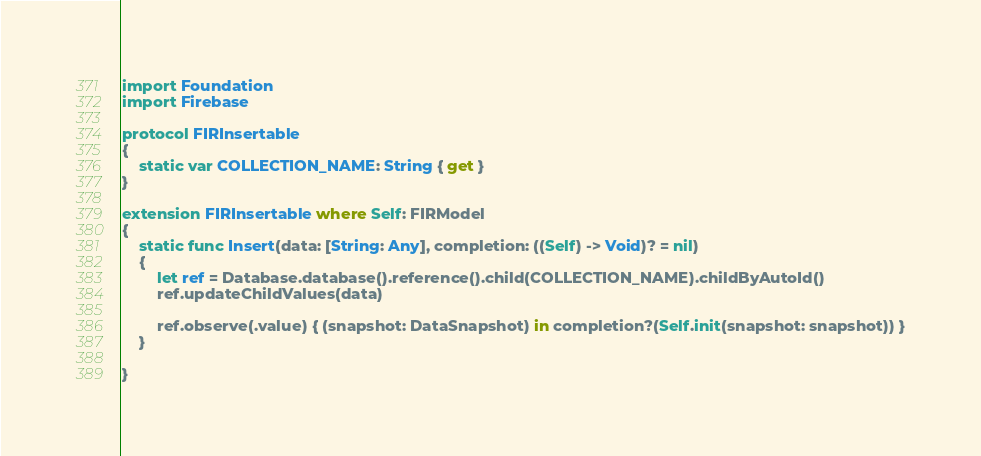<code> <loc_0><loc_0><loc_500><loc_500><_Swift_>import Foundation
import Firebase

protocol FIRInsertable
{
    static var COLLECTION_NAME: String { get }
}

extension FIRInsertable where Self: FIRModel
{
    static func Insert(data: [String: Any], completion: ((Self) -> Void)? = nil)
    {
        let ref = Database.database().reference().child(COLLECTION_NAME).childByAutoId()
        ref.updateChildValues(data)
        
        ref.observe(.value) { (snapshot: DataSnapshot) in completion?(Self.init(snapshot: snapshot)) }
    }
    
}
</code> 